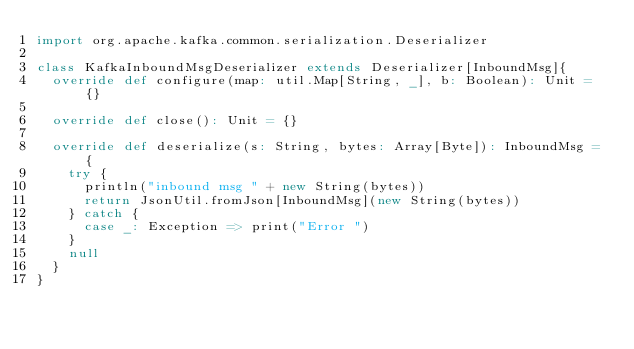<code> <loc_0><loc_0><loc_500><loc_500><_Scala_>import org.apache.kafka.common.serialization.Deserializer

class KafkaInboundMsgDeserializer extends Deserializer[InboundMsg]{
  override def configure(map: util.Map[String, _], b: Boolean): Unit = {}

  override def close(): Unit = {}

  override def deserialize(s: String, bytes: Array[Byte]): InboundMsg = {
    try {
      println("inbound msg " + new String(bytes))
      return JsonUtil.fromJson[InboundMsg](new String(bytes))
    } catch {
      case _: Exception => print("Error ")
    }
    null
  }
}
</code> 